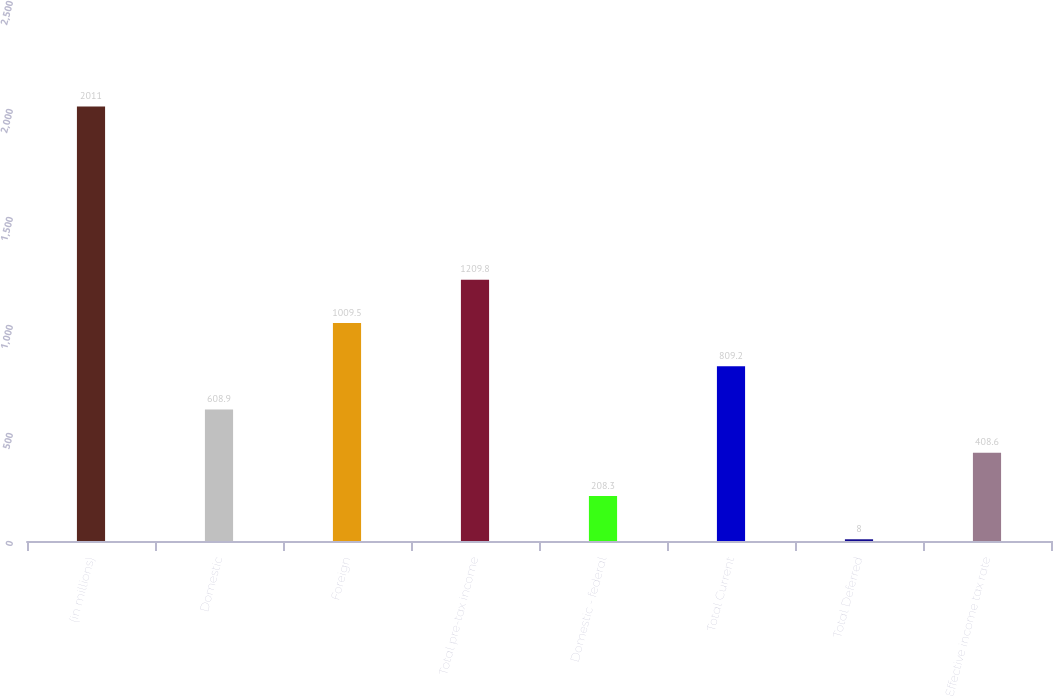<chart> <loc_0><loc_0><loc_500><loc_500><bar_chart><fcel>(in millions)<fcel>Domestic<fcel>Foreign<fcel>Total pre-tax income<fcel>Domestic - federal<fcel>Total Current<fcel>Total Deferred<fcel>Effective income tax rate<nl><fcel>2011<fcel>608.9<fcel>1009.5<fcel>1209.8<fcel>208.3<fcel>809.2<fcel>8<fcel>408.6<nl></chart> 